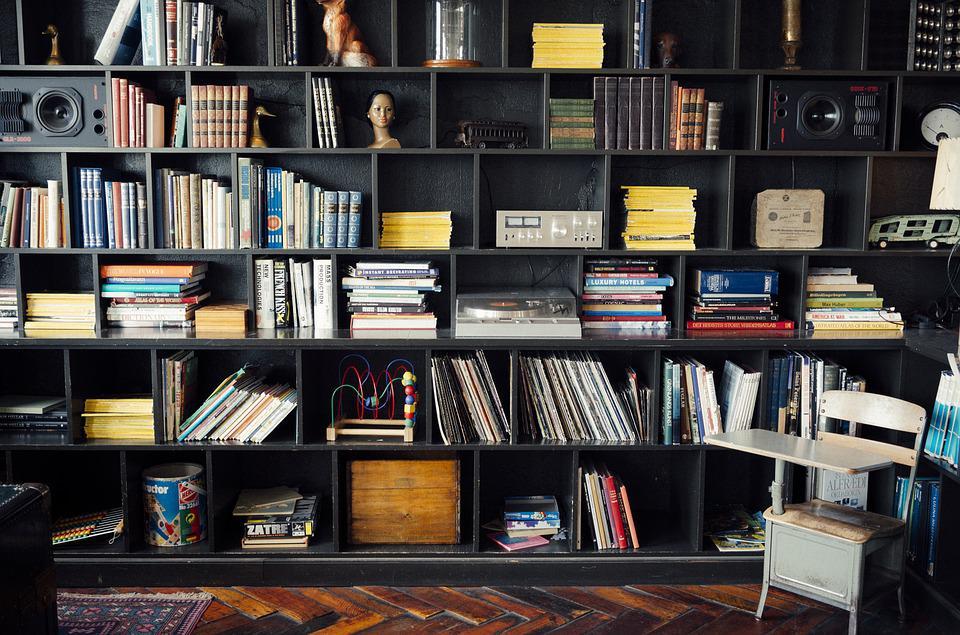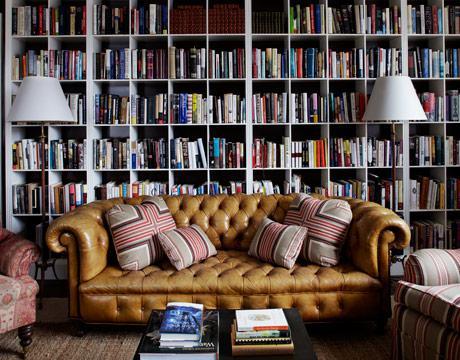The first image is the image on the left, the second image is the image on the right. Examine the images to the left and right. Is the description "In one image, at least one lamp and seating are next to a shelving unit." accurate? Answer yes or no. Yes. The first image is the image on the left, the second image is the image on the right. Evaluate the accuracy of this statement regarding the images: "An image includes at least one dark bookcase.". Is it true? Answer yes or no. Yes. 